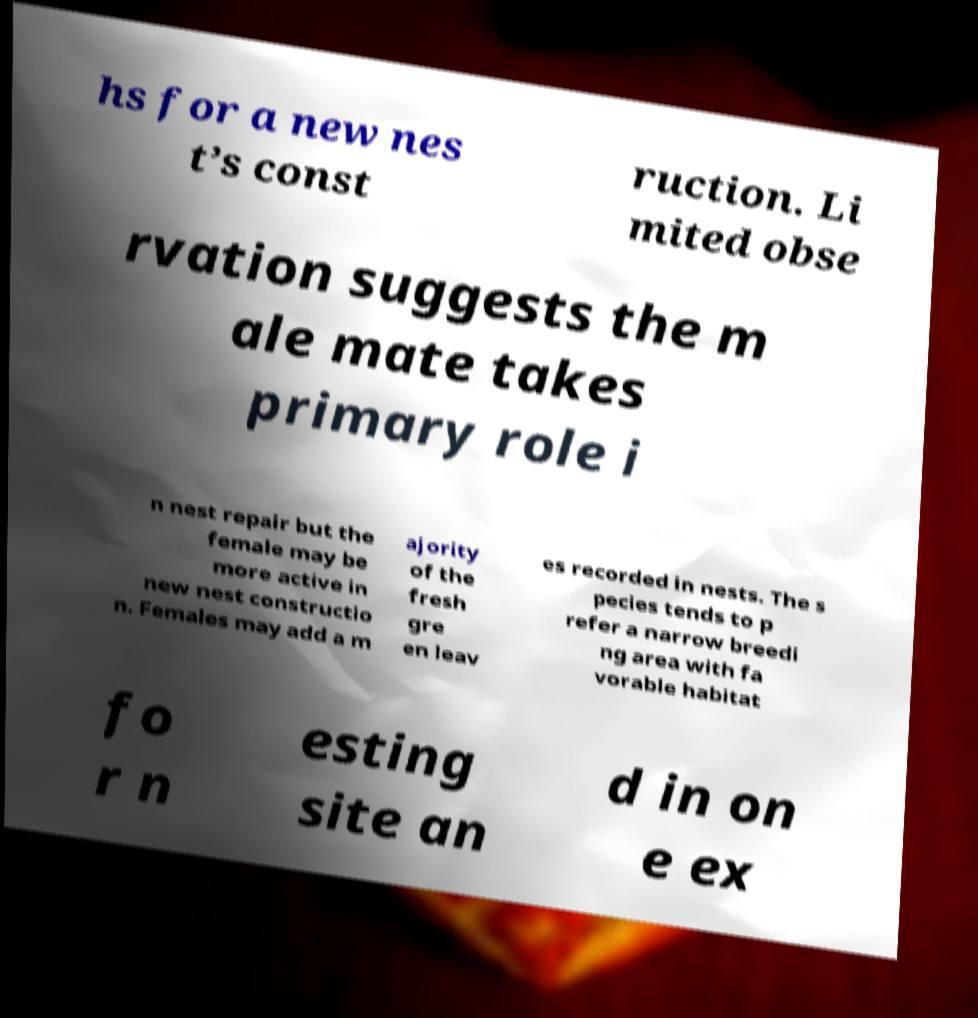There's text embedded in this image that I need extracted. Can you transcribe it verbatim? hs for a new nes t’s const ruction. Li mited obse rvation suggests the m ale mate takes primary role i n nest repair but the female may be more active in new nest constructio n. Females may add a m ajority of the fresh gre en leav es recorded in nests. The s pecies tends to p refer a narrow breedi ng area with fa vorable habitat fo r n esting site an d in on e ex 